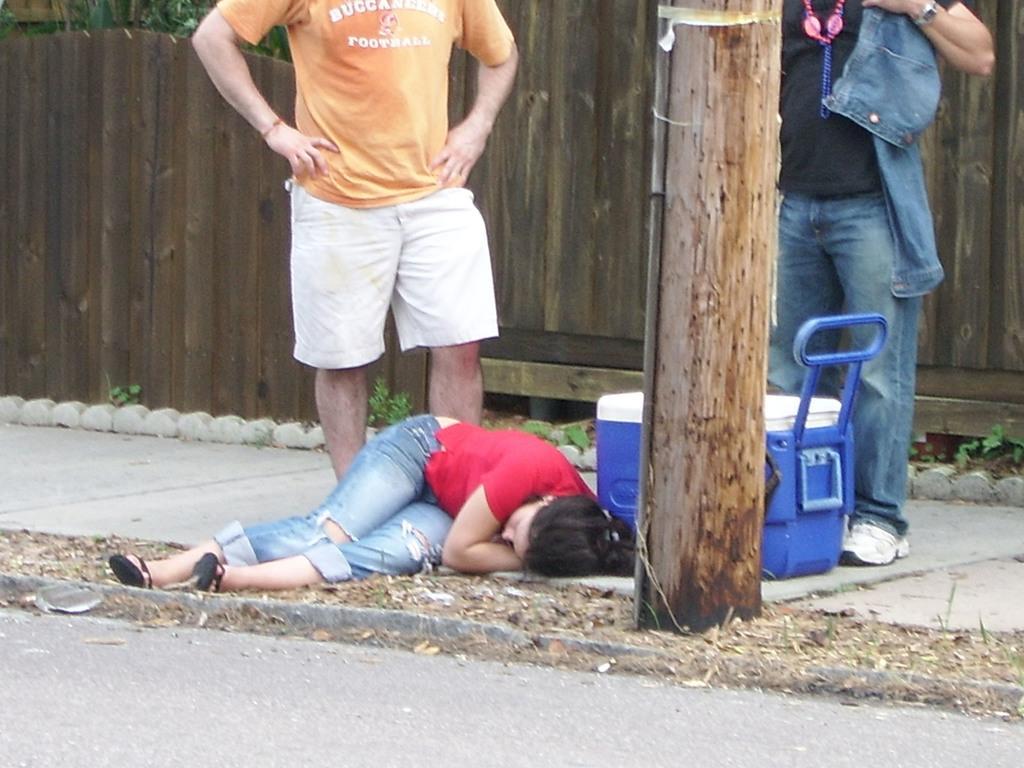In one or two sentences, can you explain what this image depicts? In this image, we can see a lady lying on the road and there is a box. In the background, we can see people standing and one of them is wearing a chain and a coat and there is a pole and we can see plants and a fence. 